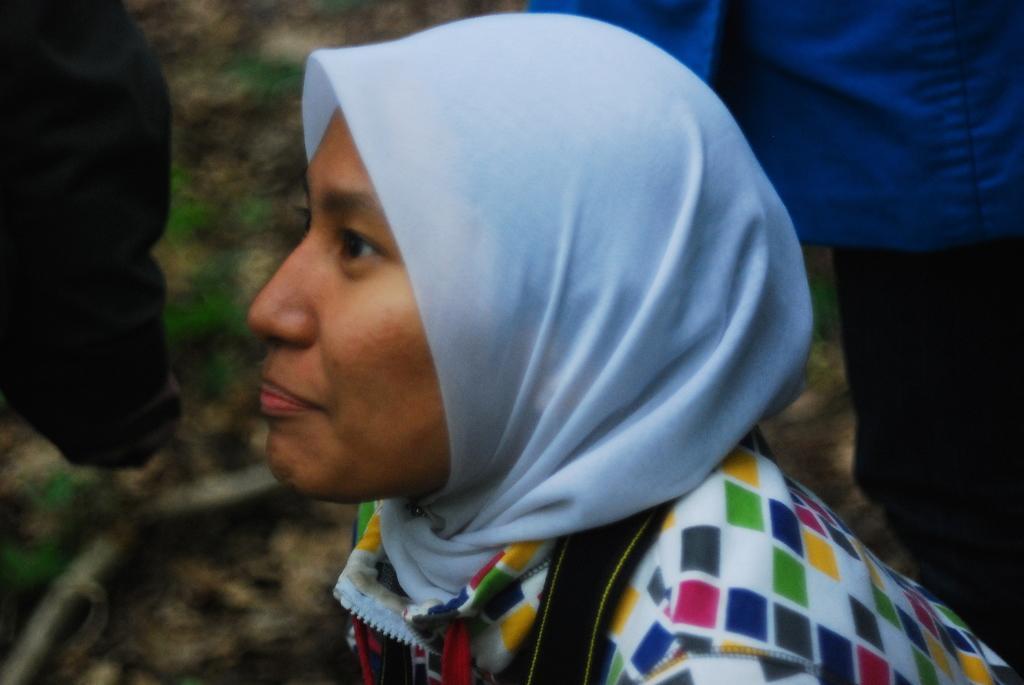Describe this image in one or two sentences. In this picture I can see a woman with a scarf, there are clothes, and there is blur background. 